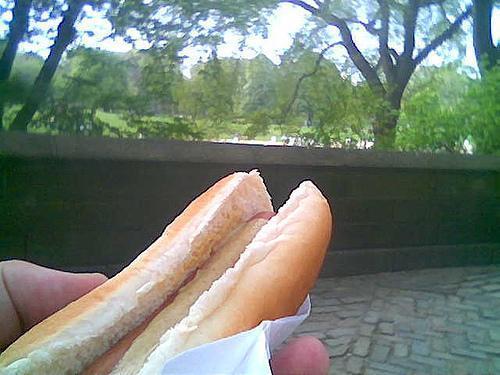Is "The hot dog is below the person." an appropriate description for the image?
Answer yes or no. No. 